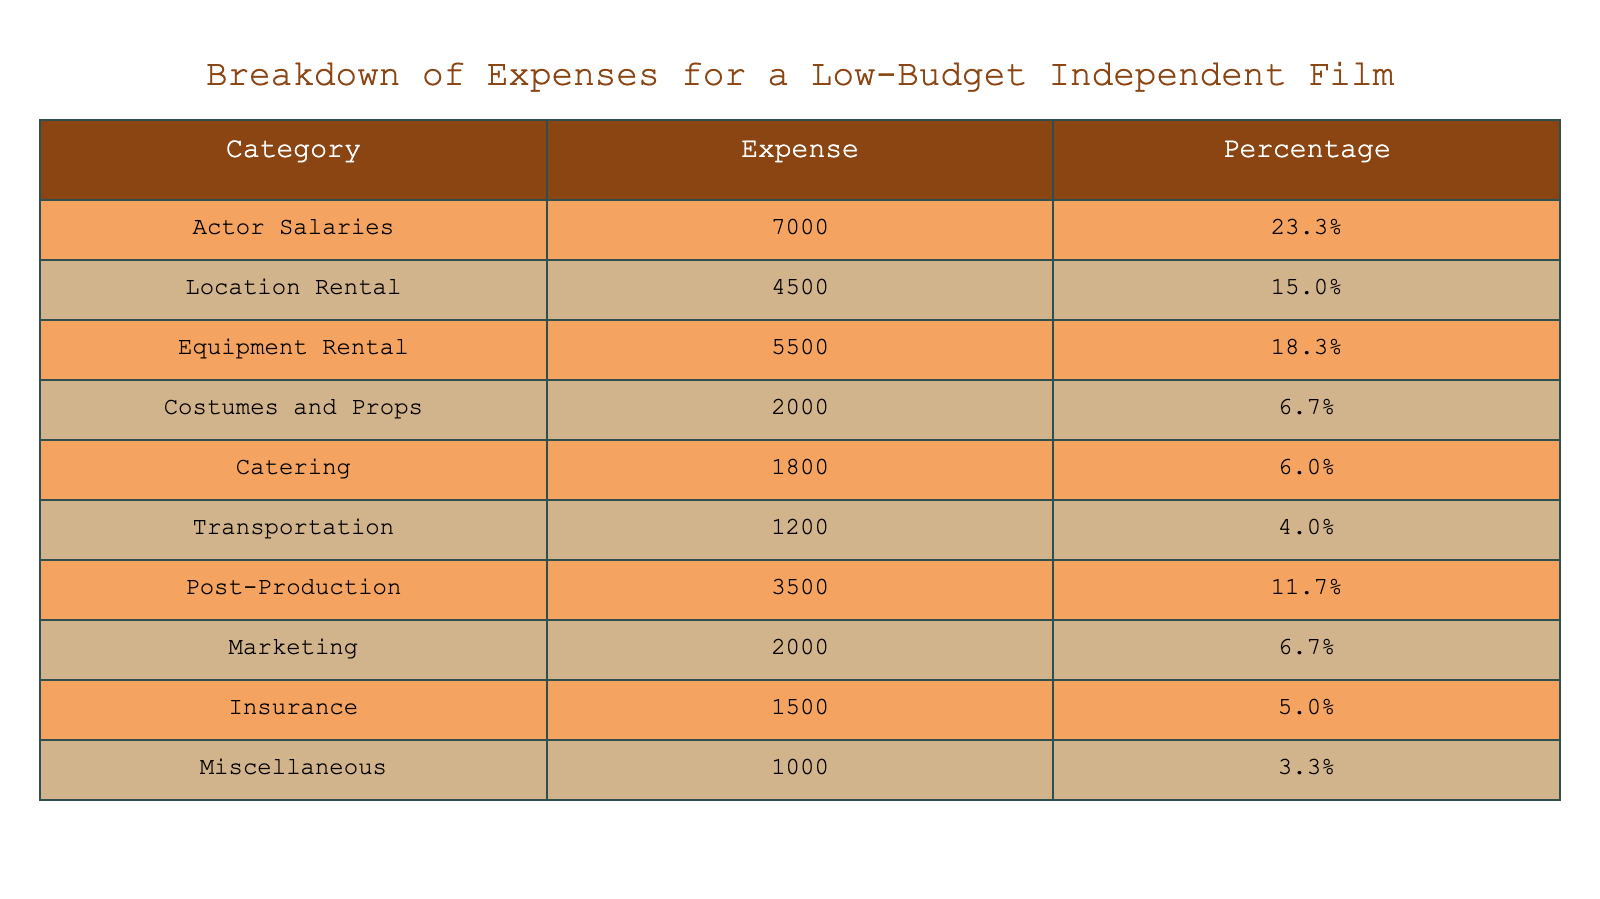What is the highest category of expense in this film production? The table shows that "Actor Salaries" has the highest expense at 7000.
Answer: 7000 What percentage of the total expenses does "Location Rental" account for? According to the table, "Location Rental" accounts for 15.0% of the total expenses.
Answer: 15.0% What are the combined expenses of "Costumes and Props" and "Catering"? The expense for "Costumes and Props" is 2000 and "Catering" is 1800. Summing these gives 2000 + 1800 = 3800.
Answer: 3800 Is the expense for "Marketing" higher than that for "Transportation"? The table shows that "Marketing" has an expense of 2000, while "Transportation" has 1200. Since 2000 is greater than 1200, the statement is true.
Answer: Yes What is the total percentage of expenses for "Post-Production" and "Insurance"? "Post-Production" is 11.7% and "Insurance" is 5.0%. Adding these together gives 11.7 + 5.0 = 16.7%.
Answer: 16.7% How much do "Equipment Rental" and "Actor Salaries" together account for as a percentage? "Equipment Rental" is 18.3% and "Actor Salaries" is 23.3%. Adding these percentages gives 18.3 + 23.3 = 41.6%.
Answer: 41.6% Which expense category has the least amount allocated in the budget? The table indicates that "Miscellaneous" has the least amount allocated at 1000.
Answer: 1000 Is the expense for "Catering" equal to that for "Insurance"? The table shows that "Catering" has an expense of 1800 and "Insurance" has 1500. Since 1800 is not equal to 1500, the answer is false.
Answer: No What is the total expense on "Actor Salaries", "Catering", and "Transportation"? The expenses for these categories are 7000 (Actor Salaries), 1800 (Catering), and 1200 (Transportation). Summing these gives 7000 + 1800 + 1200 = 10000.
Answer: 10000 